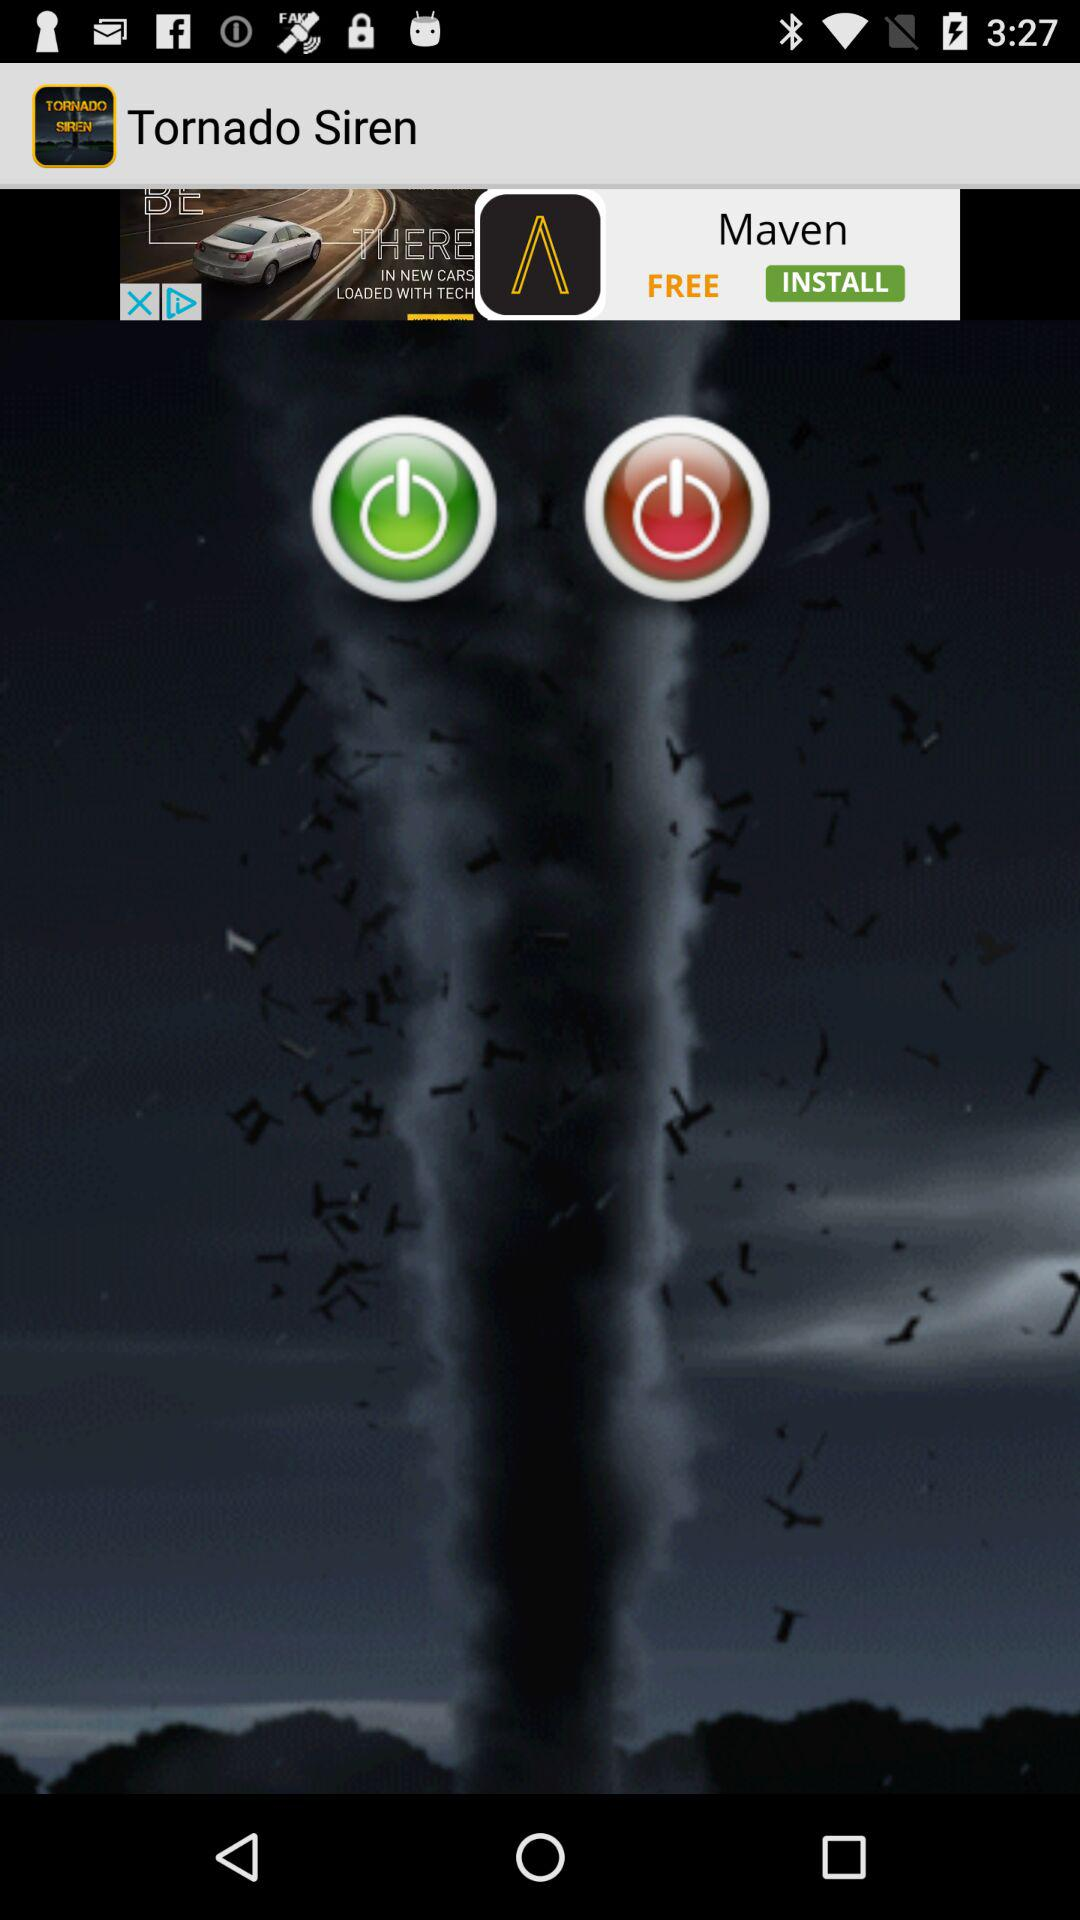What is the name of the application? The name of the application is "Tornado Siren". 